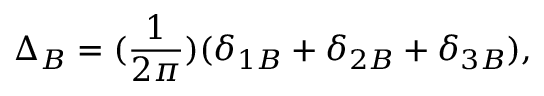<formula> <loc_0><loc_0><loc_500><loc_500>\Delta _ { B } = ( \frac { 1 } { 2 \pi } ) ( \delta _ { 1 B } + \delta _ { 2 B } + \delta _ { 3 B } ) ,</formula> 